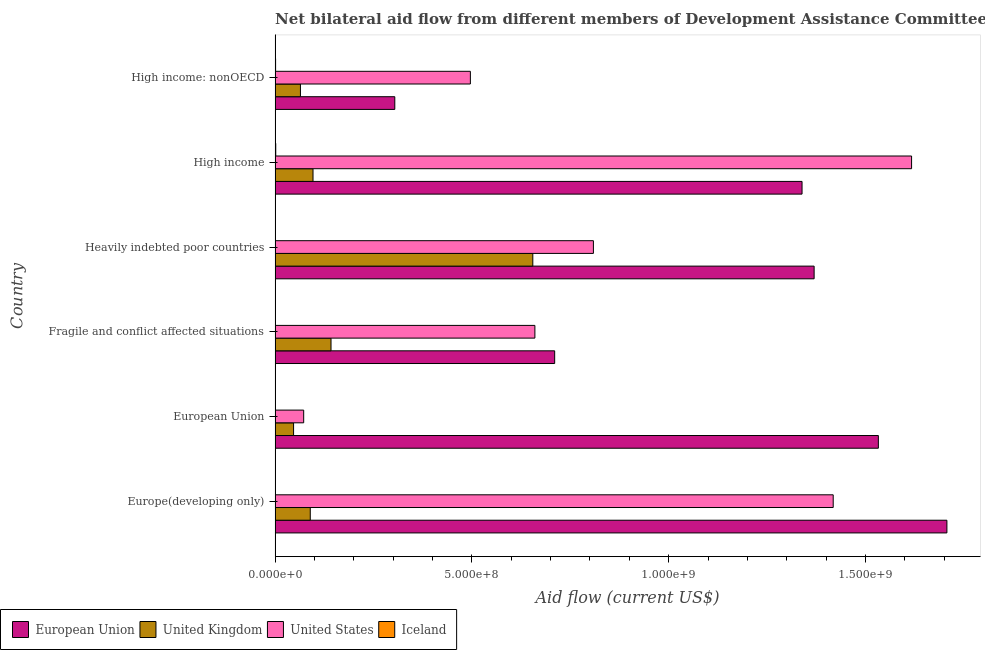How many groups of bars are there?
Your response must be concise. 6. How many bars are there on the 4th tick from the top?
Offer a very short reply. 4. What is the label of the 6th group of bars from the top?
Your answer should be very brief. Europe(developing only). What is the amount of aid given by us in High income?
Provide a succinct answer. 1.62e+09. Across all countries, what is the maximum amount of aid given by eu?
Ensure brevity in your answer.  1.71e+09. Across all countries, what is the minimum amount of aid given by eu?
Your response must be concise. 3.04e+08. In which country was the amount of aid given by eu maximum?
Offer a terse response. Europe(developing only). What is the total amount of aid given by iceland in the graph?
Your response must be concise. 5.00e+06. What is the difference between the amount of aid given by iceland in European Union and that in Heavily indebted poor countries?
Provide a short and direct response. 2.10e+05. What is the difference between the amount of aid given by iceland in Heavily indebted poor countries and the amount of aid given by uk in Fragile and conflict affected situations?
Ensure brevity in your answer.  -1.42e+08. What is the average amount of aid given by eu per country?
Provide a short and direct response. 1.16e+09. What is the difference between the amount of aid given by iceland and amount of aid given by eu in Europe(developing only)?
Keep it short and to the point. -1.71e+09. What is the ratio of the amount of aid given by us in Europe(developing only) to that in High income: nonOECD?
Provide a succinct answer. 2.86. What is the difference between the highest and the second highest amount of aid given by uk?
Your answer should be very brief. 5.13e+08. What is the difference between the highest and the lowest amount of aid given by iceland?
Your response must be concise. 1.39e+06. Is it the case that in every country, the sum of the amount of aid given by uk and amount of aid given by eu is greater than the sum of amount of aid given by us and amount of aid given by iceland?
Give a very brief answer. Yes. Are all the bars in the graph horizontal?
Provide a succinct answer. Yes. How many countries are there in the graph?
Offer a very short reply. 6. What is the difference between two consecutive major ticks on the X-axis?
Your answer should be very brief. 5.00e+08. Are the values on the major ticks of X-axis written in scientific E-notation?
Ensure brevity in your answer.  Yes. Does the graph contain any zero values?
Provide a short and direct response. No. Does the graph contain grids?
Give a very brief answer. No. How are the legend labels stacked?
Your answer should be compact. Horizontal. What is the title of the graph?
Your answer should be compact. Net bilateral aid flow from different members of Development Assistance Committee in the year 1998. What is the label or title of the X-axis?
Provide a succinct answer. Aid flow (current US$). What is the label or title of the Y-axis?
Offer a very short reply. Country. What is the Aid flow (current US$) of European Union in Europe(developing only)?
Provide a succinct answer. 1.71e+09. What is the Aid flow (current US$) of United Kingdom in Europe(developing only)?
Provide a succinct answer. 8.94e+07. What is the Aid flow (current US$) in United States in Europe(developing only)?
Provide a short and direct response. 1.42e+09. What is the Aid flow (current US$) in Iceland in Europe(developing only)?
Provide a succinct answer. 8.30e+05. What is the Aid flow (current US$) of European Union in European Union?
Provide a short and direct response. 1.53e+09. What is the Aid flow (current US$) in United Kingdom in European Union?
Offer a very short reply. 4.70e+07. What is the Aid flow (current US$) of United States in European Union?
Offer a very short reply. 7.27e+07. What is the Aid flow (current US$) of Iceland in European Union?
Ensure brevity in your answer.  5.30e+05. What is the Aid flow (current US$) of European Union in Fragile and conflict affected situations?
Your response must be concise. 7.10e+08. What is the Aid flow (current US$) in United Kingdom in Fragile and conflict affected situations?
Your answer should be very brief. 1.42e+08. What is the Aid flow (current US$) in United States in Fragile and conflict affected situations?
Provide a short and direct response. 6.60e+08. What is the Aid flow (current US$) of Iceland in Fragile and conflict affected situations?
Offer a very short reply. 3.20e+05. What is the Aid flow (current US$) in European Union in Heavily indebted poor countries?
Give a very brief answer. 1.37e+09. What is the Aid flow (current US$) in United Kingdom in Heavily indebted poor countries?
Offer a terse response. 6.55e+08. What is the Aid flow (current US$) in United States in Heavily indebted poor countries?
Provide a succinct answer. 8.09e+08. What is the Aid flow (current US$) in European Union in High income?
Your answer should be very brief. 1.34e+09. What is the Aid flow (current US$) of United Kingdom in High income?
Offer a very short reply. 9.64e+07. What is the Aid flow (current US$) of United States in High income?
Your response must be concise. 1.62e+09. What is the Aid flow (current US$) in Iceland in High income?
Your answer should be compact. 1.71e+06. What is the Aid flow (current US$) in European Union in High income: nonOECD?
Offer a terse response. 3.04e+08. What is the Aid flow (current US$) in United Kingdom in High income: nonOECD?
Offer a very short reply. 6.44e+07. What is the Aid flow (current US$) in United States in High income: nonOECD?
Provide a short and direct response. 4.96e+08. What is the Aid flow (current US$) in Iceland in High income: nonOECD?
Your response must be concise. 1.29e+06. Across all countries, what is the maximum Aid flow (current US$) in European Union?
Make the answer very short. 1.71e+09. Across all countries, what is the maximum Aid flow (current US$) in United Kingdom?
Provide a short and direct response. 6.55e+08. Across all countries, what is the maximum Aid flow (current US$) in United States?
Keep it short and to the point. 1.62e+09. Across all countries, what is the maximum Aid flow (current US$) in Iceland?
Offer a terse response. 1.71e+06. Across all countries, what is the minimum Aid flow (current US$) in European Union?
Your answer should be compact. 3.04e+08. Across all countries, what is the minimum Aid flow (current US$) of United Kingdom?
Your answer should be very brief. 4.70e+07. Across all countries, what is the minimum Aid flow (current US$) in United States?
Give a very brief answer. 7.27e+07. Across all countries, what is the minimum Aid flow (current US$) of Iceland?
Offer a very short reply. 3.20e+05. What is the total Aid flow (current US$) of European Union in the graph?
Keep it short and to the point. 6.96e+09. What is the total Aid flow (current US$) of United Kingdom in the graph?
Offer a terse response. 1.09e+09. What is the total Aid flow (current US$) in United States in the graph?
Keep it short and to the point. 5.07e+09. What is the difference between the Aid flow (current US$) in European Union in Europe(developing only) and that in European Union?
Offer a very short reply. 1.74e+08. What is the difference between the Aid flow (current US$) of United Kingdom in Europe(developing only) and that in European Union?
Offer a very short reply. 4.24e+07. What is the difference between the Aid flow (current US$) of United States in Europe(developing only) and that in European Union?
Make the answer very short. 1.35e+09. What is the difference between the Aid flow (current US$) of Iceland in Europe(developing only) and that in European Union?
Offer a very short reply. 3.00e+05. What is the difference between the Aid flow (current US$) of European Union in Europe(developing only) and that in Fragile and conflict affected situations?
Your answer should be very brief. 9.96e+08. What is the difference between the Aid flow (current US$) in United Kingdom in Europe(developing only) and that in Fragile and conflict affected situations?
Your answer should be very brief. -5.27e+07. What is the difference between the Aid flow (current US$) of United States in Europe(developing only) and that in Fragile and conflict affected situations?
Your answer should be compact. 7.58e+08. What is the difference between the Aid flow (current US$) of Iceland in Europe(developing only) and that in Fragile and conflict affected situations?
Offer a very short reply. 5.10e+05. What is the difference between the Aid flow (current US$) in European Union in Europe(developing only) and that in Heavily indebted poor countries?
Give a very brief answer. 3.37e+08. What is the difference between the Aid flow (current US$) in United Kingdom in Europe(developing only) and that in Heavily indebted poor countries?
Offer a very short reply. -5.65e+08. What is the difference between the Aid flow (current US$) in United States in Europe(developing only) and that in Heavily indebted poor countries?
Provide a succinct answer. 6.09e+08. What is the difference between the Aid flow (current US$) of Iceland in Europe(developing only) and that in Heavily indebted poor countries?
Provide a short and direct response. 5.10e+05. What is the difference between the Aid flow (current US$) in European Union in Europe(developing only) and that in High income?
Make the answer very short. 3.68e+08. What is the difference between the Aid flow (current US$) of United Kingdom in Europe(developing only) and that in High income?
Make the answer very short. -6.97e+06. What is the difference between the Aid flow (current US$) in United States in Europe(developing only) and that in High income?
Your answer should be very brief. -1.99e+08. What is the difference between the Aid flow (current US$) of Iceland in Europe(developing only) and that in High income?
Keep it short and to the point. -8.80e+05. What is the difference between the Aid flow (current US$) in European Union in Europe(developing only) and that in High income: nonOECD?
Provide a succinct answer. 1.40e+09. What is the difference between the Aid flow (current US$) in United Kingdom in Europe(developing only) and that in High income: nonOECD?
Your answer should be compact. 2.50e+07. What is the difference between the Aid flow (current US$) in United States in Europe(developing only) and that in High income: nonOECD?
Keep it short and to the point. 9.22e+08. What is the difference between the Aid flow (current US$) in Iceland in Europe(developing only) and that in High income: nonOECD?
Offer a terse response. -4.60e+05. What is the difference between the Aid flow (current US$) of European Union in European Union and that in Fragile and conflict affected situations?
Make the answer very short. 8.22e+08. What is the difference between the Aid flow (current US$) in United Kingdom in European Union and that in Fragile and conflict affected situations?
Your answer should be compact. -9.51e+07. What is the difference between the Aid flow (current US$) of United States in European Union and that in Fragile and conflict affected situations?
Offer a terse response. -5.87e+08. What is the difference between the Aid flow (current US$) of European Union in European Union and that in Heavily indebted poor countries?
Provide a succinct answer. 1.63e+08. What is the difference between the Aid flow (current US$) in United Kingdom in European Union and that in Heavily indebted poor countries?
Keep it short and to the point. -6.08e+08. What is the difference between the Aid flow (current US$) of United States in European Union and that in Heavily indebted poor countries?
Ensure brevity in your answer.  -7.36e+08. What is the difference between the Aid flow (current US$) of Iceland in European Union and that in Heavily indebted poor countries?
Ensure brevity in your answer.  2.10e+05. What is the difference between the Aid flow (current US$) in European Union in European Union and that in High income?
Provide a short and direct response. 1.94e+08. What is the difference between the Aid flow (current US$) of United Kingdom in European Union and that in High income?
Ensure brevity in your answer.  -4.94e+07. What is the difference between the Aid flow (current US$) in United States in European Union and that in High income?
Provide a short and direct response. -1.54e+09. What is the difference between the Aid flow (current US$) in Iceland in European Union and that in High income?
Your answer should be compact. -1.18e+06. What is the difference between the Aid flow (current US$) in European Union in European Union and that in High income: nonOECD?
Give a very brief answer. 1.23e+09. What is the difference between the Aid flow (current US$) of United Kingdom in European Union and that in High income: nonOECD?
Provide a short and direct response. -1.74e+07. What is the difference between the Aid flow (current US$) of United States in European Union and that in High income: nonOECD?
Your answer should be very brief. -4.23e+08. What is the difference between the Aid flow (current US$) of Iceland in European Union and that in High income: nonOECD?
Give a very brief answer. -7.60e+05. What is the difference between the Aid flow (current US$) in European Union in Fragile and conflict affected situations and that in Heavily indebted poor countries?
Your answer should be very brief. -6.59e+08. What is the difference between the Aid flow (current US$) in United Kingdom in Fragile and conflict affected situations and that in Heavily indebted poor countries?
Your response must be concise. -5.13e+08. What is the difference between the Aid flow (current US$) of United States in Fragile and conflict affected situations and that in Heavily indebted poor countries?
Provide a short and direct response. -1.49e+08. What is the difference between the Aid flow (current US$) in Iceland in Fragile and conflict affected situations and that in Heavily indebted poor countries?
Your answer should be very brief. 0. What is the difference between the Aid flow (current US$) in European Union in Fragile and conflict affected situations and that in High income?
Keep it short and to the point. -6.28e+08. What is the difference between the Aid flow (current US$) in United Kingdom in Fragile and conflict affected situations and that in High income?
Give a very brief answer. 4.58e+07. What is the difference between the Aid flow (current US$) in United States in Fragile and conflict affected situations and that in High income?
Provide a succinct answer. -9.57e+08. What is the difference between the Aid flow (current US$) of Iceland in Fragile and conflict affected situations and that in High income?
Ensure brevity in your answer.  -1.39e+06. What is the difference between the Aid flow (current US$) of European Union in Fragile and conflict affected situations and that in High income: nonOECD?
Your answer should be very brief. 4.06e+08. What is the difference between the Aid flow (current US$) in United Kingdom in Fragile and conflict affected situations and that in High income: nonOECD?
Your response must be concise. 7.77e+07. What is the difference between the Aid flow (current US$) in United States in Fragile and conflict affected situations and that in High income: nonOECD?
Ensure brevity in your answer.  1.64e+08. What is the difference between the Aid flow (current US$) in Iceland in Fragile and conflict affected situations and that in High income: nonOECD?
Keep it short and to the point. -9.70e+05. What is the difference between the Aid flow (current US$) in European Union in Heavily indebted poor countries and that in High income?
Your answer should be very brief. 3.07e+07. What is the difference between the Aid flow (current US$) in United Kingdom in Heavily indebted poor countries and that in High income?
Your response must be concise. 5.58e+08. What is the difference between the Aid flow (current US$) in United States in Heavily indebted poor countries and that in High income?
Give a very brief answer. -8.08e+08. What is the difference between the Aid flow (current US$) in Iceland in Heavily indebted poor countries and that in High income?
Your answer should be compact. -1.39e+06. What is the difference between the Aid flow (current US$) of European Union in Heavily indebted poor countries and that in High income: nonOECD?
Offer a very short reply. 1.07e+09. What is the difference between the Aid flow (current US$) of United Kingdom in Heavily indebted poor countries and that in High income: nonOECD?
Ensure brevity in your answer.  5.90e+08. What is the difference between the Aid flow (current US$) of United States in Heavily indebted poor countries and that in High income: nonOECD?
Keep it short and to the point. 3.13e+08. What is the difference between the Aid flow (current US$) of Iceland in Heavily indebted poor countries and that in High income: nonOECD?
Your response must be concise. -9.70e+05. What is the difference between the Aid flow (current US$) in European Union in High income and that in High income: nonOECD?
Your response must be concise. 1.03e+09. What is the difference between the Aid flow (current US$) in United Kingdom in High income and that in High income: nonOECD?
Offer a very short reply. 3.20e+07. What is the difference between the Aid flow (current US$) in United States in High income and that in High income: nonOECD?
Make the answer very short. 1.12e+09. What is the difference between the Aid flow (current US$) of Iceland in High income and that in High income: nonOECD?
Provide a succinct answer. 4.20e+05. What is the difference between the Aid flow (current US$) in European Union in Europe(developing only) and the Aid flow (current US$) in United Kingdom in European Union?
Give a very brief answer. 1.66e+09. What is the difference between the Aid flow (current US$) in European Union in Europe(developing only) and the Aid flow (current US$) in United States in European Union?
Offer a terse response. 1.63e+09. What is the difference between the Aid flow (current US$) in European Union in Europe(developing only) and the Aid flow (current US$) in Iceland in European Union?
Offer a terse response. 1.71e+09. What is the difference between the Aid flow (current US$) of United Kingdom in Europe(developing only) and the Aid flow (current US$) of United States in European Union?
Keep it short and to the point. 1.67e+07. What is the difference between the Aid flow (current US$) in United Kingdom in Europe(developing only) and the Aid flow (current US$) in Iceland in European Union?
Provide a succinct answer. 8.89e+07. What is the difference between the Aid flow (current US$) in United States in Europe(developing only) and the Aid flow (current US$) in Iceland in European Union?
Ensure brevity in your answer.  1.42e+09. What is the difference between the Aid flow (current US$) in European Union in Europe(developing only) and the Aid flow (current US$) in United Kingdom in Fragile and conflict affected situations?
Provide a short and direct response. 1.56e+09. What is the difference between the Aid flow (current US$) of European Union in Europe(developing only) and the Aid flow (current US$) of United States in Fragile and conflict affected situations?
Make the answer very short. 1.05e+09. What is the difference between the Aid flow (current US$) in European Union in Europe(developing only) and the Aid flow (current US$) in Iceland in Fragile and conflict affected situations?
Provide a short and direct response. 1.71e+09. What is the difference between the Aid flow (current US$) of United Kingdom in Europe(developing only) and the Aid flow (current US$) of United States in Fragile and conflict affected situations?
Offer a terse response. -5.71e+08. What is the difference between the Aid flow (current US$) in United Kingdom in Europe(developing only) and the Aid flow (current US$) in Iceland in Fragile and conflict affected situations?
Provide a short and direct response. 8.91e+07. What is the difference between the Aid flow (current US$) of United States in Europe(developing only) and the Aid flow (current US$) of Iceland in Fragile and conflict affected situations?
Provide a succinct answer. 1.42e+09. What is the difference between the Aid flow (current US$) in European Union in Europe(developing only) and the Aid flow (current US$) in United Kingdom in Heavily indebted poor countries?
Provide a short and direct response. 1.05e+09. What is the difference between the Aid flow (current US$) in European Union in Europe(developing only) and the Aid flow (current US$) in United States in Heavily indebted poor countries?
Your response must be concise. 8.98e+08. What is the difference between the Aid flow (current US$) of European Union in Europe(developing only) and the Aid flow (current US$) of Iceland in Heavily indebted poor countries?
Your answer should be compact. 1.71e+09. What is the difference between the Aid flow (current US$) in United Kingdom in Europe(developing only) and the Aid flow (current US$) in United States in Heavily indebted poor countries?
Offer a terse response. -7.19e+08. What is the difference between the Aid flow (current US$) of United Kingdom in Europe(developing only) and the Aid flow (current US$) of Iceland in Heavily indebted poor countries?
Your response must be concise. 8.91e+07. What is the difference between the Aid flow (current US$) in United States in Europe(developing only) and the Aid flow (current US$) in Iceland in Heavily indebted poor countries?
Make the answer very short. 1.42e+09. What is the difference between the Aid flow (current US$) of European Union in Europe(developing only) and the Aid flow (current US$) of United Kingdom in High income?
Provide a short and direct response. 1.61e+09. What is the difference between the Aid flow (current US$) of European Union in Europe(developing only) and the Aid flow (current US$) of United States in High income?
Ensure brevity in your answer.  8.98e+07. What is the difference between the Aid flow (current US$) of European Union in Europe(developing only) and the Aid flow (current US$) of Iceland in High income?
Provide a succinct answer. 1.71e+09. What is the difference between the Aid flow (current US$) in United Kingdom in Europe(developing only) and the Aid flow (current US$) in United States in High income?
Ensure brevity in your answer.  -1.53e+09. What is the difference between the Aid flow (current US$) in United Kingdom in Europe(developing only) and the Aid flow (current US$) in Iceland in High income?
Keep it short and to the point. 8.77e+07. What is the difference between the Aid flow (current US$) in United States in Europe(developing only) and the Aid flow (current US$) in Iceland in High income?
Your response must be concise. 1.42e+09. What is the difference between the Aid flow (current US$) of European Union in Europe(developing only) and the Aid flow (current US$) of United Kingdom in High income: nonOECD?
Offer a terse response. 1.64e+09. What is the difference between the Aid flow (current US$) of European Union in Europe(developing only) and the Aid flow (current US$) of United States in High income: nonOECD?
Offer a very short reply. 1.21e+09. What is the difference between the Aid flow (current US$) in European Union in Europe(developing only) and the Aid flow (current US$) in Iceland in High income: nonOECD?
Make the answer very short. 1.71e+09. What is the difference between the Aid flow (current US$) of United Kingdom in Europe(developing only) and the Aid flow (current US$) of United States in High income: nonOECD?
Provide a succinct answer. -4.07e+08. What is the difference between the Aid flow (current US$) of United Kingdom in Europe(developing only) and the Aid flow (current US$) of Iceland in High income: nonOECD?
Offer a terse response. 8.81e+07. What is the difference between the Aid flow (current US$) of United States in Europe(developing only) and the Aid flow (current US$) of Iceland in High income: nonOECD?
Keep it short and to the point. 1.42e+09. What is the difference between the Aid flow (current US$) of European Union in European Union and the Aid flow (current US$) of United Kingdom in Fragile and conflict affected situations?
Your response must be concise. 1.39e+09. What is the difference between the Aid flow (current US$) in European Union in European Union and the Aid flow (current US$) in United States in Fragile and conflict affected situations?
Keep it short and to the point. 8.73e+08. What is the difference between the Aid flow (current US$) in European Union in European Union and the Aid flow (current US$) in Iceland in Fragile and conflict affected situations?
Ensure brevity in your answer.  1.53e+09. What is the difference between the Aid flow (current US$) in United Kingdom in European Union and the Aid flow (current US$) in United States in Fragile and conflict affected situations?
Offer a very short reply. -6.13e+08. What is the difference between the Aid flow (current US$) of United Kingdom in European Union and the Aid flow (current US$) of Iceland in Fragile and conflict affected situations?
Offer a very short reply. 4.67e+07. What is the difference between the Aid flow (current US$) in United States in European Union and the Aid flow (current US$) in Iceland in Fragile and conflict affected situations?
Ensure brevity in your answer.  7.24e+07. What is the difference between the Aid flow (current US$) in European Union in European Union and the Aid flow (current US$) in United Kingdom in Heavily indebted poor countries?
Provide a succinct answer. 8.78e+08. What is the difference between the Aid flow (current US$) in European Union in European Union and the Aid flow (current US$) in United States in Heavily indebted poor countries?
Provide a succinct answer. 7.24e+08. What is the difference between the Aid flow (current US$) of European Union in European Union and the Aid flow (current US$) of Iceland in Heavily indebted poor countries?
Provide a succinct answer. 1.53e+09. What is the difference between the Aid flow (current US$) in United Kingdom in European Union and the Aid flow (current US$) in United States in Heavily indebted poor countries?
Provide a succinct answer. -7.62e+08. What is the difference between the Aid flow (current US$) in United Kingdom in European Union and the Aid flow (current US$) in Iceland in Heavily indebted poor countries?
Ensure brevity in your answer.  4.67e+07. What is the difference between the Aid flow (current US$) of United States in European Union and the Aid flow (current US$) of Iceland in Heavily indebted poor countries?
Make the answer very short. 7.24e+07. What is the difference between the Aid flow (current US$) in European Union in European Union and the Aid flow (current US$) in United Kingdom in High income?
Keep it short and to the point. 1.44e+09. What is the difference between the Aid flow (current US$) of European Union in European Union and the Aid flow (current US$) of United States in High income?
Your answer should be compact. -8.44e+07. What is the difference between the Aid flow (current US$) of European Union in European Union and the Aid flow (current US$) of Iceland in High income?
Make the answer very short. 1.53e+09. What is the difference between the Aid flow (current US$) of United Kingdom in European Union and the Aid flow (current US$) of United States in High income?
Provide a succinct answer. -1.57e+09. What is the difference between the Aid flow (current US$) of United Kingdom in European Union and the Aid flow (current US$) of Iceland in High income?
Your answer should be compact. 4.53e+07. What is the difference between the Aid flow (current US$) of United States in European Union and the Aid flow (current US$) of Iceland in High income?
Make the answer very short. 7.10e+07. What is the difference between the Aid flow (current US$) of European Union in European Union and the Aid flow (current US$) of United Kingdom in High income: nonOECD?
Your answer should be very brief. 1.47e+09. What is the difference between the Aid flow (current US$) in European Union in European Union and the Aid flow (current US$) in United States in High income: nonOECD?
Offer a terse response. 1.04e+09. What is the difference between the Aid flow (current US$) of European Union in European Union and the Aid flow (current US$) of Iceland in High income: nonOECD?
Your answer should be very brief. 1.53e+09. What is the difference between the Aid flow (current US$) in United Kingdom in European Union and the Aid flow (current US$) in United States in High income: nonOECD?
Make the answer very short. -4.49e+08. What is the difference between the Aid flow (current US$) in United Kingdom in European Union and the Aid flow (current US$) in Iceland in High income: nonOECD?
Ensure brevity in your answer.  4.57e+07. What is the difference between the Aid flow (current US$) of United States in European Union and the Aid flow (current US$) of Iceland in High income: nonOECD?
Your response must be concise. 7.14e+07. What is the difference between the Aid flow (current US$) of European Union in Fragile and conflict affected situations and the Aid flow (current US$) of United Kingdom in Heavily indebted poor countries?
Keep it short and to the point. 5.55e+07. What is the difference between the Aid flow (current US$) of European Union in Fragile and conflict affected situations and the Aid flow (current US$) of United States in Heavily indebted poor countries?
Provide a succinct answer. -9.84e+07. What is the difference between the Aid flow (current US$) of European Union in Fragile and conflict affected situations and the Aid flow (current US$) of Iceland in Heavily indebted poor countries?
Make the answer very short. 7.10e+08. What is the difference between the Aid flow (current US$) in United Kingdom in Fragile and conflict affected situations and the Aid flow (current US$) in United States in Heavily indebted poor countries?
Give a very brief answer. -6.67e+08. What is the difference between the Aid flow (current US$) in United Kingdom in Fragile and conflict affected situations and the Aid flow (current US$) in Iceland in Heavily indebted poor countries?
Ensure brevity in your answer.  1.42e+08. What is the difference between the Aid flow (current US$) of United States in Fragile and conflict affected situations and the Aid flow (current US$) of Iceland in Heavily indebted poor countries?
Keep it short and to the point. 6.60e+08. What is the difference between the Aid flow (current US$) of European Union in Fragile and conflict affected situations and the Aid flow (current US$) of United Kingdom in High income?
Your response must be concise. 6.14e+08. What is the difference between the Aid flow (current US$) of European Union in Fragile and conflict affected situations and the Aid flow (current US$) of United States in High income?
Your response must be concise. -9.07e+08. What is the difference between the Aid flow (current US$) of European Union in Fragile and conflict affected situations and the Aid flow (current US$) of Iceland in High income?
Provide a succinct answer. 7.09e+08. What is the difference between the Aid flow (current US$) in United Kingdom in Fragile and conflict affected situations and the Aid flow (current US$) in United States in High income?
Give a very brief answer. -1.47e+09. What is the difference between the Aid flow (current US$) of United Kingdom in Fragile and conflict affected situations and the Aid flow (current US$) of Iceland in High income?
Ensure brevity in your answer.  1.40e+08. What is the difference between the Aid flow (current US$) in United States in Fragile and conflict affected situations and the Aid flow (current US$) in Iceland in High income?
Your answer should be very brief. 6.58e+08. What is the difference between the Aid flow (current US$) in European Union in Fragile and conflict affected situations and the Aid flow (current US$) in United Kingdom in High income: nonOECD?
Make the answer very short. 6.46e+08. What is the difference between the Aid flow (current US$) of European Union in Fragile and conflict affected situations and the Aid flow (current US$) of United States in High income: nonOECD?
Ensure brevity in your answer.  2.14e+08. What is the difference between the Aid flow (current US$) in European Union in Fragile and conflict affected situations and the Aid flow (current US$) in Iceland in High income: nonOECD?
Your response must be concise. 7.09e+08. What is the difference between the Aid flow (current US$) in United Kingdom in Fragile and conflict affected situations and the Aid flow (current US$) in United States in High income: nonOECD?
Keep it short and to the point. -3.54e+08. What is the difference between the Aid flow (current US$) of United Kingdom in Fragile and conflict affected situations and the Aid flow (current US$) of Iceland in High income: nonOECD?
Make the answer very short. 1.41e+08. What is the difference between the Aid flow (current US$) in United States in Fragile and conflict affected situations and the Aid flow (current US$) in Iceland in High income: nonOECD?
Your answer should be very brief. 6.59e+08. What is the difference between the Aid flow (current US$) in European Union in Heavily indebted poor countries and the Aid flow (current US$) in United Kingdom in High income?
Offer a terse response. 1.27e+09. What is the difference between the Aid flow (current US$) in European Union in Heavily indebted poor countries and the Aid flow (current US$) in United States in High income?
Your answer should be very brief. -2.48e+08. What is the difference between the Aid flow (current US$) in European Union in Heavily indebted poor countries and the Aid flow (current US$) in Iceland in High income?
Ensure brevity in your answer.  1.37e+09. What is the difference between the Aid flow (current US$) of United Kingdom in Heavily indebted poor countries and the Aid flow (current US$) of United States in High income?
Offer a very short reply. -9.62e+08. What is the difference between the Aid flow (current US$) in United Kingdom in Heavily indebted poor countries and the Aid flow (current US$) in Iceland in High income?
Your answer should be very brief. 6.53e+08. What is the difference between the Aid flow (current US$) of United States in Heavily indebted poor countries and the Aid flow (current US$) of Iceland in High income?
Provide a succinct answer. 8.07e+08. What is the difference between the Aid flow (current US$) of European Union in Heavily indebted poor countries and the Aid flow (current US$) of United Kingdom in High income: nonOECD?
Ensure brevity in your answer.  1.31e+09. What is the difference between the Aid flow (current US$) of European Union in Heavily indebted poor countries and the Aid flow (current US$) of United States in High income: nonOECD?
Provide a succinct answer. 8.73e+08. What is the difference between the Aid flow (current US$) of European Union in Heavily indebted poor countries and the Aid flow (current US$) of Iceland in High income: nonOECD?
Keep it short and to the point. 1.37e+09. What is the difference between the Aid flow (current US$) of United Kingdom in Heavily indebted poor countries and the Aid flow (current US$) of United States in High income: nonOECD?
Provide a short and direct response. 1.59e+08. What is the difference between the Aid flow (current US$) in United Kingdom in Heavily indebted poor countries and the Aid flow (current US$) in Iceland in High income: nonOECD?
Offer a very short reply. 6.54e+08. What is the difference between the Aid flow (current US$) of United States in Heavily indebted poor countries and the Aid flow (current US$) of Iceland in High income: nonOECD?
Keep it short and to the point. 8.07e+08. What is the difference between the Aid flow (current US$) in European Union in High income and the Aid flow (current US$) in United Kingdom in High income: nonOECD?
Provide a short and direct response. 1.27e+09. What is the difference between the Aid flow (current US$) in European Union in High income and the Aid flow (current US$) in United States in High income: nonOECD?
Your answer should be very brief. 8.43e+08. What is the difference between the Aid flow (current US$) of European Union in High income and the Aid flow (current US$) of Iceland in High income: nonOECD?
Give a very brief answer. 1.34e+09. What is the difference between the Aid flow (current US$) in United Kingdom in High income and the Aid flow (current US$) in United States in High income: nonOECD?
Your answer should be very brief. -4.00e+08. What is the difference between the Aid flow (current US$) in United Kingdom in High income and the Aid flow (current US$) in Iceland in High income: nonOECD?
Your answer should be very brief. 9.51e+07. What is the difference between the Aid flow (current US$) of United States in High income and the Aid flow (current US$) of Iceland in High income: nonOECD?
Give a very brief answer. 1.62e+09. What is the average Aid flow (current US$) in European Union per country?
Offer a very short reply. 1.16e+09. What is the average Aid flow (current US$) of United Kingdom per country?
Your response must be concise. 1.82e+08. What is the average Aid flow (current US$) in United States per country?
Make the answer very short. 8.45e+08. What is the average Aid flow (current US$) in Iceland per country?
Ensure brevity in your answer.  8.33e+05. What is the difference between the Aid flow (current US$) of European Union and Aid flow (current US$) of United Kingdom in Europe(developing only)?
Keep it short and to the point. 1.62e+09. What is the difference between the Aid flow (current US$) in European Union and Aid flow (current US$) in United States in Europe(developing only)?
Your answer should be very brief. 2.89e+08. What is the difference between the Aid flow (current US$) in European Union and Aid flow (current US$) in Iceland in Europe(developing only)?
Make the answer very short. 1.71e+09. What is the difference between the Aid flow (current US$) of United Kingdom and Aid flow (current US$) of United States in Europe(developing only)?
Keep it short and to the point. -1.33e+09. What is the difference between the Aid flow (current US$) of United Kingdom and Aid flow (current US$) of Iceland in Europe(developing only)?
Your answer should be very brief. 8.86e+07. What is the difference between the Aid flow (current US$) in United States and Aid flow (current US$) in Iceland in Europe(developing only)?
Your response must be concise. 1.42e+09. What is the difference between the Aid flow (current US$) in European Union and Aid flow (current US$) in United Kingdom in European Union?
Your response must be concise. 1.49e+09. What is the difference between the Aid flow (current US$) in European Union and Aid flow (current US$) in United States in European Union?
Keep it short and to the point. 1.46e+09. What is the difference between the Aid flow (current US$) of European Union and Aid flow (current US$) of Iceland in European Union?
Offer a very short reply. 1.53e+09. What is the difference between the Aid flow (current US$) of United Kingdom and Aid flow (current US$) of United States in European Union?
Your answer should be very brief. -2.57e+07. What is the difference between the Aid flow (current US$) of United Kingdom and Aid flow (current US$) of Iceland in European Union?
Your answer should be compact. 4.65e+07. What is the difference between the Aid flow (current US$) in United States and Aid flow (current US$) in Iceland in European Union?
Provide a short and direct response. 7.21e+07. What is the difference between the Aid flow (current US$) of European Union and Aid flow (current US$) of United Kingdom in Fragile and conflict affected situations?
Ensure brevity in your answer.  5.68e+08. What is the difference between the Aid flow (current US$) of European Union and Aid flow (current US$) of United States in Fragile and conflict affected situations?
Give a very brief answer. 5.03e+07. What is the difference between the Aid flow (current US$) of European Union and Aid flow (current US$) of Iceland in Fragile and conflict affected situations?
Give a very brief answer. 7.10e+08. What is the difference between the Aid flow (current US$) in United Kingdom and Aid flow (current US$) in United States in Fragile and conflict affected situations?
Make the answer very short. -5.18e+08. What is the difference between the Aid flow (current US$) in United Kingdom and Aid flow (current US$) in Iceland in Fragile and conflict affected situations?
Offer a very short reply. 1.42e+08. What is the difference between the Aid flow (current US$) in United States and Aid flow (current US$) in Iceland in Fragile and conflict affected situations?
Provide a succinct answer. 6.60e+08. What is the difference between the Aid flow (current US$) of European Union and Aid flow (current US$) of United Kingdom in Heavily indebted poor countries?
Make the answer very short. 7.15e+08. What is the difference between the Aid flow (current US$) in European Union and Aid flow (current US$) in United States in Heavily indebted poor countries?
Offer a terse response. 5.61e+08. What is the difference between the Aid flow (current US$) in European Union and Aid flow (current US$) in Iceland in Heavily indebted poor countries?
Make the answer very short. 1.37e+09. What is the difference between the Aid flow (current US$) of United Kingdom and Aid flow (current US$) of United States in Heavily indebted poor countries?
Your response must be concise. -1.54e+08. What is the difference between the Aid flow (current US$) in United Kingdom and Aid flow (current US$) in Iceland in Heavily indebted poor countries?
Ensure brevity in your answer.  6.54e+08. What is the difference between the Aid flow (current US$) in United States and Aid flow (current US$) in Iceland in Heavily indebted poor countries?
Offer a terse response. 8.08e+08. What is the difference between the Aid flow (current US$) of European Union and Aid flow (current US$) of United Kingdom in High income?
Your response must be concise. 1.24e+09. What is the difference between the Aid flow (current US$) in European Union and Aid flow (current US$) in United States in High income?
Your response must be concise. -2.78e+08. What is the difference between the Aid flow (current US$) in European Union and Aid flow (current US$) in Iceland in High income?
Offer a terse response. 1.34e+09. What is the difference between the Aid flow (current US$) in United Kingdom and Aid flow (current US$) in United States in High income?
Offer a terse response. -1.52e+09. What is the difference between the Aid flow (current US$) in United Kingdom and Aid flow (current US$) in Iceland in High income?
Keep it short and to the point. 9.47e+07. What is the difference between the Aid flow (current US$) in United States and Aid flow (current US$) in Iceland in High income?
Offer a terse response. 1.62e+09. What is the difference between the Aid flow (current US$) in European Union and Aid flow (current US$) in United Kingdom in High income: nonOECD?
Offer a terse response. 2.40e+08. What is the difference between the Aid flow (current US$) of European Union and Aid flow (current US$) of United States in High income: nonOECD?
Your answer should be very brief. -1.92e+08. What is the difference between the Aid flow (current US$) in European Union and Aid flow (current US$) in Iceland in High income: nonOECD?
Keep it short and to the point. 3.03e+08. What is the difference between the Aid flow (current US$) of United Kingdom and Aid flow (current US$) of United States in High income: nonOECD?
Your response must be concise. -4.32e+08. What is the difference between the Aid flow (current US$) of United Kingdom and Aid flow (current US$) of Iceland in High income: nonOECD?
Make the answer very short. 6.31e+07. What is the difference between the Aid flow (current US$) in United States and Aid flow (current US$) in Iceland in High income: nonOECD?
Ensure brevity in your answer.  4.95e+08. What is the ratio of the Aid flow (current US$) in European Union in Europe(developing only) to that in European Union?
Offer a terse response. 1.11. What is the ratio of the Aid flow (current US$) of United Kingdom in Europe(developing only) to that in European Union?
Make the answer very short. 1.9. What is the ratio of the Aid flow (current US$) of United States in Europe(developing only) to that in European Union?
Offer a very short reply. 19.51. What is the ratio of the Aid flow (current US$) in Iceland in Europe(developing only) to that in European Union?
Provide a succinct answer. 1.57. What is the ratio of the Aid flow (current US$) in European Union in Europe(developing only) to that in Fragile and conflict affected situations?
Provide a short and direct response. 2.4. What is the ratio of the Aid flow (current US$) of United Kingdom in Europe(developing only) to that in Fragile and conflict affected situations?
Keep it short and to the point. 0.63. What is the ratio of the Aid flow (current US$) in United States in Europe(developing only) to that in Fragile and conflict affected situations?
Ensure brevity in your answer.  2.15. What is the ratio of the Aid flow (current US$) in Iceland in Europe(developing only) to that in Fragile and conflict affected situations?
Your answer should be very brief. 2.59. What is the ratio of the Aid flow (current US$) of European Union in Europe(developing only) to that in Heavily indebted poor countries?
Offer a terse response. 1.25. What is the ratio of the Aid flow (current US$) in United Kingdom in Europe(developing only) to that in Heavily indebted poor countries?
Provide a short and direct response. 0.14. What is the ratio of the Aid flow (current US$) in United States in Europe(developing only) to that in Heavily indebted poor countries?
Offer a terse response. 1.75. What is the ratio of the Aid flow (current US$) in Iceland in Europe(developing only) to that in Heavily indebted poor countries?
Make the answer very short. 2.59. What is the ratio of the Aid flow (current US$) in European Union in Europe(developing only) to that in High income?
Offer a terse response. 1.27. What is the ratio of the Aid flow (current US$) of United Kingdom in Europe(developing only) to that in High income?
Your response must be concise. 0.93. What is the ratio of the Aid flow (current US$) in United States in Europe(developing only) to that in High income?
Your answer should be very brief. 0.88. What is the ratio of the Aid flow (current US$) of Iceland in Europe(developing only) to that in High income?
Offer a very short reply. 0.49. What is the ratio of the Aid flow (current US$) in European Union in Europe(developing only) to that in High income: nonOECD?
Give a very brief answer. 5.61. What is the ratio of the Aid flow (current US$) in United Kingdom in Europe(developing only) to that in High income: nonOECD?
Ensure brevity in your answer.  1.39. What is the ratio of the Aid flow (current US$) of United States in Europe(developing only) to that in High income: nonOECD?
Your answer should be very brief. 2.86. What is the ratio of the Aid flow (current US$) of Iceland in Europe(developing only) to that in High income: nonOECD?
Provide a succinct answer. 0.64. What is the ratio of the Aid flow (current US$) in European Union in European Union to that in Fragile and conflict affected situations?
Your answer should be compact. 2.16. What is the ratio of the Aid flow (current US$) of United Kingdom in European Union to that in Fragile and conflict affected situations?
Your response must be concise. 0.33. What is the ratio of the Aid flow (current US$) in United States in European Union to that in Fragile and conflict affected situations?
Your answer should be very brief. 0.11. What is the ratio of the Aid flow (current US$) of Iceland in European Union to that in Fragile and conflict affected situations?
Your answer should be very brief. 1.66. What is the ratio of the Aid flow (current US$) in European Union in European Union to that in Heavily indebted poor countries?
Keep it short and to the point. 1.12. What is the ratio of the Aid flow (current US$) in United Kingdom in European Union to that in Heavily indebted poor countries?
Provide a short and direct response. 0.07. What is the ratio of the Aid flow (current US$) of United States in European Union to that in Heavily indebted poor countries?
Ensure brevity in your answer.  0.09. What is the ratio of the Aid flow (current US$) of Iceland in European Union to that in Heavily indebted poor countries?
Give a very brief answer. 1.66. What is the ratio of the Aid flow (current US$) in European Union in European Union to that in High income?
Your response must be concise. 1.14. What is the ratio of the Aid flow (current US$) of United Kingdom in European Union to that in High income?
Provide a short and direct response. 0.49. What is the ratio of the Aid flow (current US$) in United States in European Union to that in High income?
Your answer should be compact. 0.04. What is the ratio of the Aid flow (current US$) in Iceland in European Union to that in High income?
Your response must be concise. 0.31. What is the ratio of the Aid flow (current US$) in European Union in European Union to that in High income: nonOECD?
Offer a very short reply. 5.04. What is the ratio of the Aid flow (current US$) of United Kingdom in European Union to that in High income: nonOECD?
Provide a succinct answer. 0.73. What is the ratio of the Aid flow (current US$) of United States in European Union to that in High income: nonOECD?
Provide a short and direct response. 0.15. What is the ratio of the Aid flow (current US$) in Iceland in European Union to that in High income: nonOECD?
Ensure brevity in your answer.  0.41. What is the ratio of the Aid flow (current US$) in European Union in Fragile and conflict affected situations to that in Heavily indebted poor countries?
Your response must be concise. 0.52. What is the ratio of the Aid flow (current US$) of United Kingdom in Fragile and conflict affected situations to that in Heavily indebted poor countries?
Provide a short and direct response. 0.22. What is the ratio of the Aid flow (current US$) of United States in Fragile and conflict affected situations to that in Heavily indebted poor countries?
Provide a short and direct response. 0.82. What is the ratio of the Aid flow (current US$) of Iceland in Fragile and conflict affected situations to that in Heavily indebted poor countries?
Your answer should be compact. 1. What is the ratio of the Aid flow (current US$) of European Union in Fragile and conflict affected situations to that in High income?
Provide a short and direct response. 0.53. What is the ratio of the Aid flow (current US$) of United Kingdom in Fragile and conflict affected situations to that in High income?
Your answer should be very brief. 1.47. What is the ratio of the Aid flow (current US$) in United States in Fragile and conflict affected situations to that in High income?
Give a very brief answer. 0.41. What is the ratio of the Aid flow (current US$) in Iceland in Fragile and conflict affected situations to that in High income?
Offer a terse response. 0.19. What is the ratio of the Aid flow (current US$) in European Union in Fragile and conflict affected situations to that in High income: nonOECD?
Make the answer very short. 2.34. What is the ratio of the Aid flow (current US$) in United Kingdom in Fragile and conflict affected situations to that in High income: nonOECD?
Make the answer very short. 2.21. What is the ratio of the Aid flow (current US$) in United States in Fragile and conflict affected situations to that in High income: nonOECD?
Offer a very short reply. 1.33. What is the ratio of the Aid flow (current US$) in Iceland in Fragile and conflict affected situations to that in High income: nonOECD?
Offer a very short reply. 0.25. What is the ratio of the Aid flow (current US$) in European Union in Heavily indebted poor countries to that in High income?
Your response must be concise. 1.02. What is the ratio of the Aid flow (current US$) of United Kingdom in Heavily indebted poor countries to that in High income?
Ensure brevity in your answer.  6.79. What is the ratio of the Aid flow (current US$) in United States in Heavily indebted poor countries to that in High income?
Offer a terse response. 0.5. What is the ratio of the Aid flow (current US$) of Iceland in Heavily indebted poor countries to that in High income?
Make the answer very short. 0.19. What is the ratio of the Aid flow (current US$) in European Union in Heavily indebted poor countries to that in High income: nonOECD?
Your response must be concise. 4.5. What is the ratio of the Aid flow (current US$) of United Kingdom in Heavily indebted poor countries to that in High income: nonOECD?
Your response must be concise. 10.17. What is the ratio of the Aid flow (current US$) of United States in Heavily indebted poor countries to that in High income: nonOECD?
Your response must be concise. 1.63. What is the ratio of the Aid flow (current US$) in Iceland in Heavily indebted poor countries to that in High income: nonOECD?
Ensure brevity in your answer.  0.25. What is the ratio of the Aid flow (current US$) of European Union in High income to that in High income: nonOECD?
Make the answer very short. 4.4. What is the ratio of the Aid flow (current US$) in United Kingdom in High income to that in High income: nonOECD?
Your answer should be very brief. 1.5. What is the ratio of the Aid flow (current US$) in United States in High income to that in High income: nonOECD?
Keep it short and to the point. 3.26. What is the ratio of the Aid flow (current US$) of Iceland in High income to that in High income: nonOECD?
Give a very brief answer. 1.33. What is the difference between the highest and the second highest Aid flow (current US$) in European Union?
Keep it short and to the point. 1.74e+08. What is the difference between the highest and the second highest Aid flow (current US$) in United Kingdom?
Your answer should be compact. 5.13e+08. What is the difference between the highest and the second highest Aid flow (current US$) in United States?
Offer a very short reply. 1.99e+08. What is the difference between the highest and the lowest Aid flow (current US$) in European Union?
Keep it short and to the point. 1.40e+09. What is the difference between the highest and the lowest Aid flow (current US$) in United Kingdom?
Provide a succinct answer. 6.08e+08. What is the difference between the highest and the lowest Aid flow (current US$) of United States?
Give a very brief answer. 1.54e+09. What is the difference between the highest and the lowest Aid flow (current US$) in Iceland?
Your answer should be very brief. 1.39e+06. 